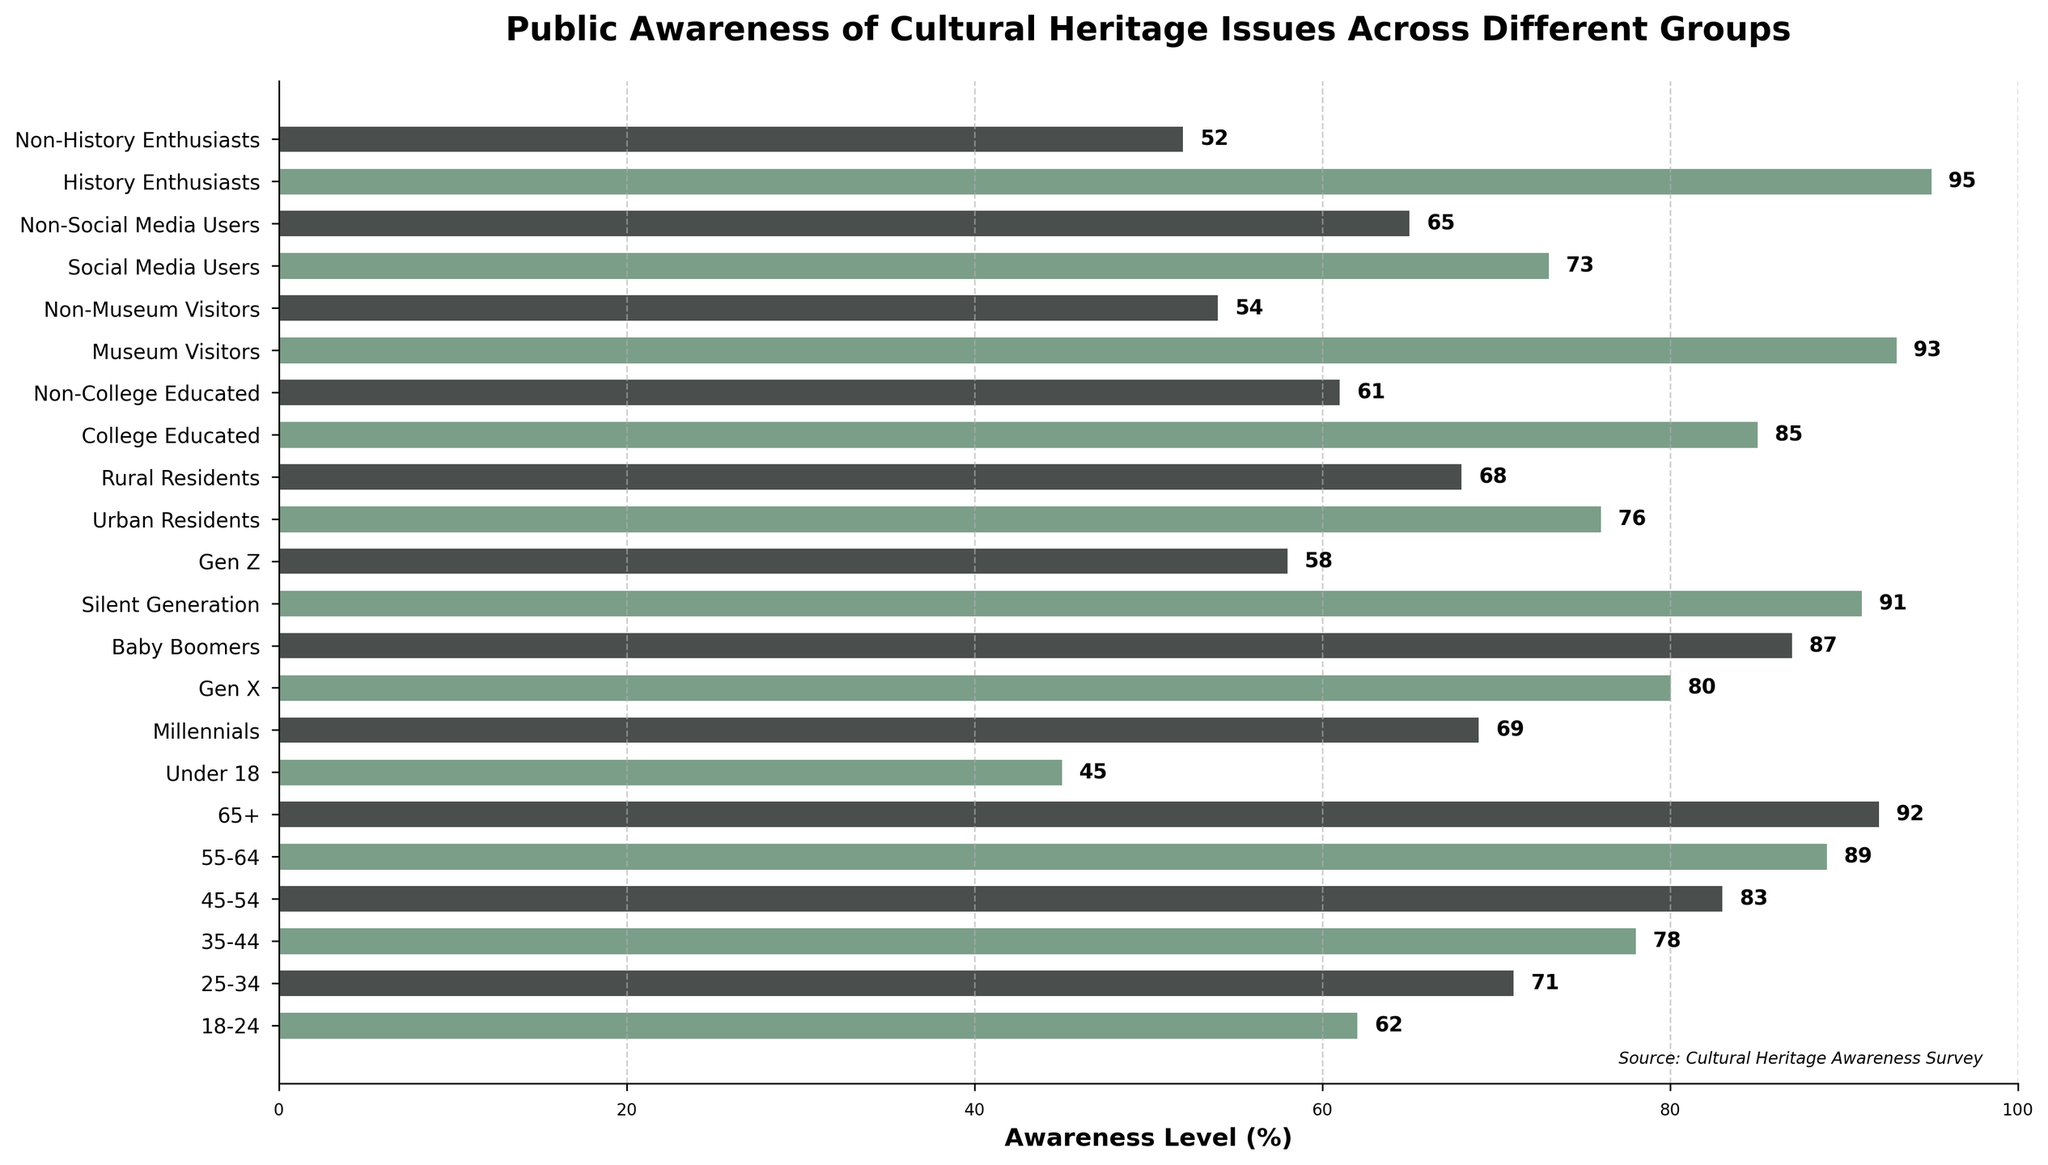What age group has the highest awareness level of cultural heritage issues? Look at the bar representing each age group and find the one with the longest bar indicating the highest percentage. The 65+ age group has the highest bar at 92%.
Answer: 65+ What is the difference in awareness level between Urban Residents and Rural Residents? Find the awareness levels for Urban Residents (76%) and Rural Residents (68%), and calculate their difference: 76% - 68% = 8%.
Answer: 8% Which has higher awareness, Non-Social Media Users or Non-Museum Visitors? Compare the bars for Non-Social Media Users (65%) and Non-Museum Visitors (54%). The bar for Non-Social Media Users is higher.
Answer: Non-Social Media Users What is the average awareness level across the listed generation groups (Millennials, Gen X, Baby Boomers, Silent Generation, Gen Z)? Add the awareness levels for the listed generations: 69% + 80% + 87% + 91% + 58% = 385%. Divide by the number of groups (5): 385% / 5 = 77%.
Answer: 77% By how much is the awareness level of College Educated individuals higher than Non-College Educated individuals? Find the awareness levels for College Educated (85%) and Non-College Educated (61%), and calculate the difference: 85% - 61% = 24%.
Answer: 24% Which group has the lowest awareness level of cultural heritage issues? Identify the bar with the shortest length indicating the lowest percentage, which is Under 18 at 45%.
Answer: Under 18 How does the awareness level of Museum Visitors compare to History Enthusiasts? Compare the awareness levels for Museum Visitors (93%) and History Enthusiasts (95%). History Enthusiasts have a higher level.
Answer: History Enthusiasts What is the median awareness level among the given data points? Arrange the awareness levels in ascending order and find the middle value. The median value, in this case, is the average of the 10th and 11th values in the sorted list: (76 + 78) / 2 = 77%.
Answer: 77% What percentage of Social Media Users are aware of cultural heritage issues, and how does this compare to the percentage of Non-Social Media Users? Social Media Users have an awareness level of 73%, and Non-Social Media Users have an awareness level of 65%. Calculate the difference: 73% - 65% = 8%.
Answer: 8% Do Millennials have a higher awareness level than Gen Z? Compare the awareness levels for Millennials (69%) and Gen Z (58%). The bar for Millennials is higher.
Answer: Yes 